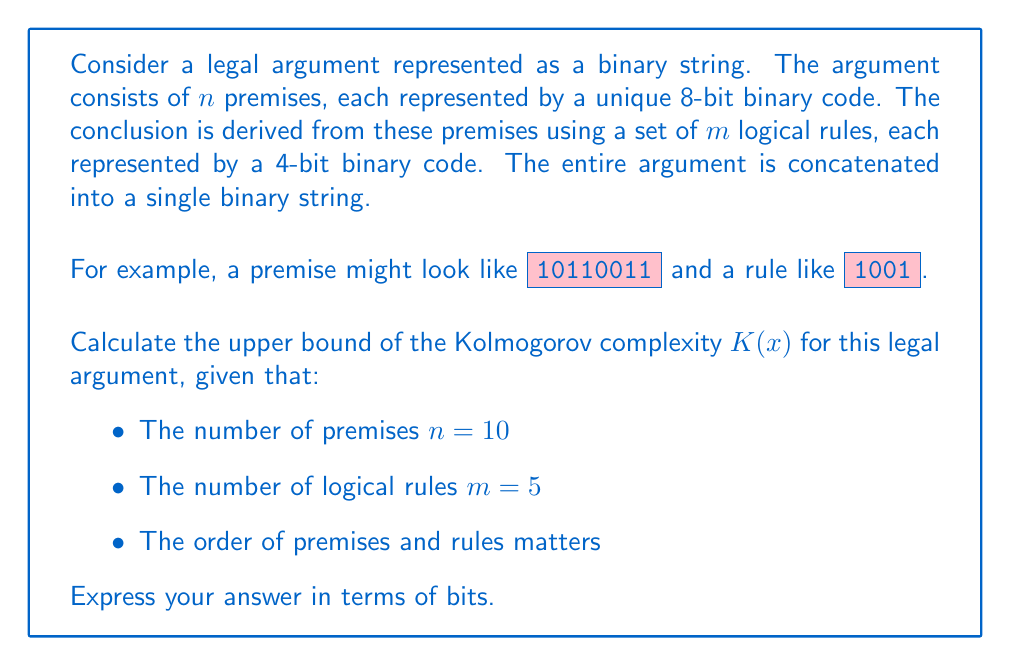Solve this math problem. To calculate the upper bound of the Kolmogorov complexity $K(x)$ for this legal argument, we need to consider the following steps:

1. Represent the premises:
   - Each premise is represented by an 8-bit code
   - There are $n = 10$ premises
   - Total bits for premises = $10 \times 8 = 80$ bits

2. Represent the logical rules:
   - Each rule is represented by a 4-bit code
   - There are $m = 5$ rules
   - Total bits for rules = $5 \times 4 = 20$ bits

3. Consider the order of premises and rules:
   - The order matters, so we need to account for the arrangement
   - For $n$ premises, we need $\log_2(n!)$ bits to specify the order
   - For $m$ rules, we need $\log_2(m!)$ bits to specify the order

4. Calculate the total upper bound:
   $$K(x) \leq 80 + 20 + \log_2(10!) + \log_2(5!) + c$$
   
   Where $c$ is a small constant for the program to interpret the string

5. Simplify:
   $$K(x) \leq 100 + \log_2(3628800) + \log_2(120) + c$$
   $$K(x) \leq 100 + 21.79 + 6.91 + c$$
   $$K(x) \leq 128.7 + c$$

6. Round up to the nearest integer (since we're dealing with bits):
   $$K(x) \leq 129 + c$$

The constant $c$ is typically small and depends on the specific programming language or model used to interpret the string. For practical purposes, we can consider it to be around 10-20 bits.
Answer: $K(x) \leq 149$ bits 